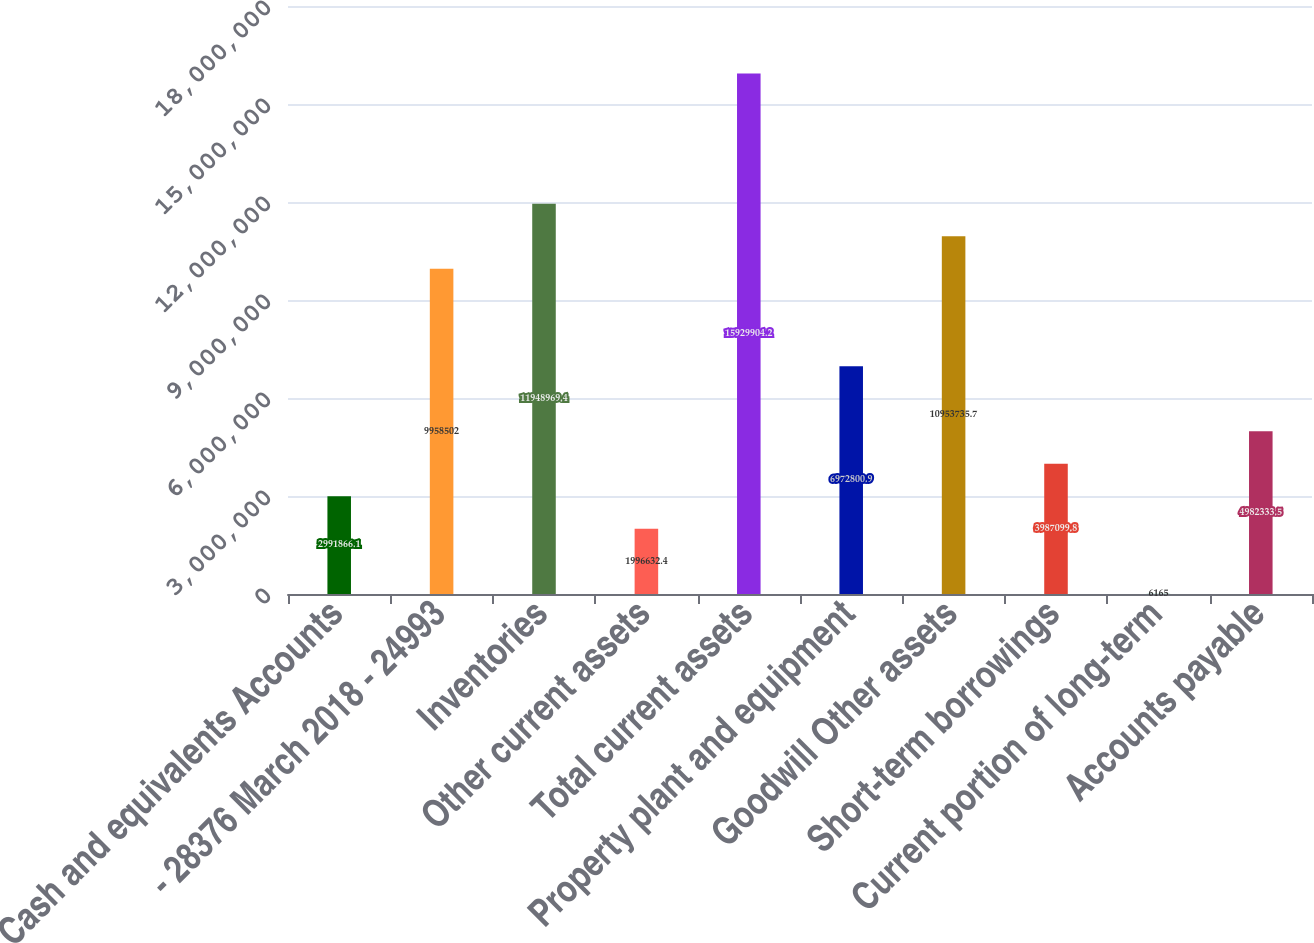Convert chart. <chart><loc_0><loc_0><loc_500><loc_500><bar_chart><fcel>Cash and equivalents Accounts<fcel>- 28376 March 2018 - 24993<fcel>Inventories<fcel>Other current assets<fcel>Total current assets<fcel>Property plant and equipment<fcel>Goodwill Other assets<fcel>Short-term borrowings<fcel>Current portion of long-term<fcel>Accounts payable<nl><fcel>2.99187e+06<fcel>9.9585e+06<fcel>1.1949e+07<fcel>1.99663e+06<fcel>1.59299e+07<fcel>6.9728e+06<fcel>1.09537e+07<fcel>3.9871e+06<fcel>6165<fcel>4.98233e+06<nl></chart> 